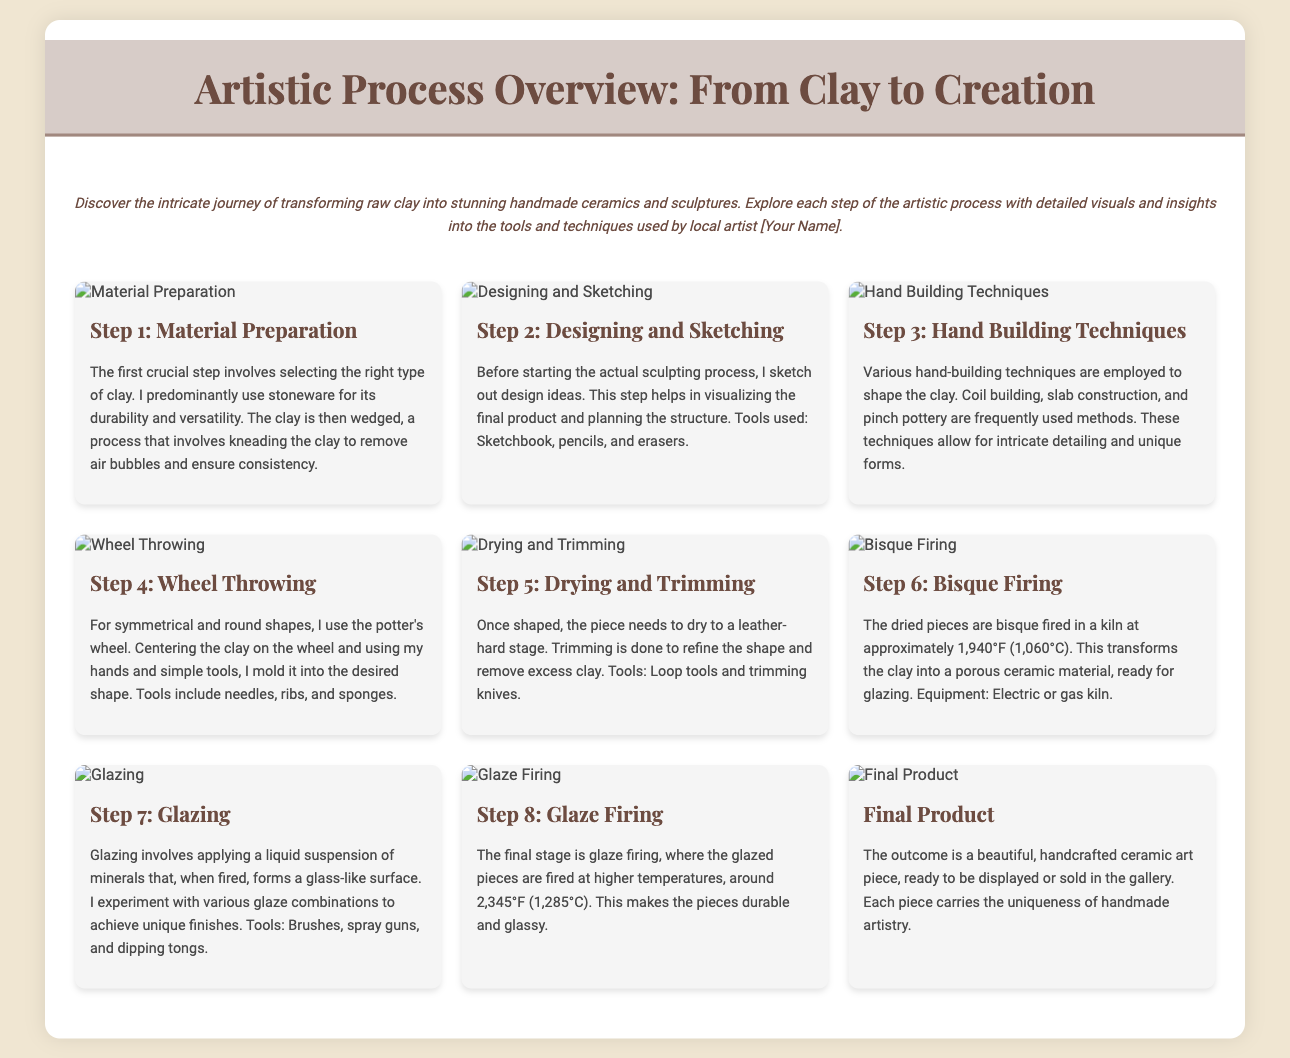what type of clay is predominantly used? The document states that stoneware is predominantly used for its durability and versatility.
Answer: stoneware what is the first step in the artistic process? The first step is Material Preparation, which includes selecting the right type of clay and wedging it.
Answer: Material Preparation which techniques are mentioned for shaping the clay? The document lists coil building, slab construction, and pinch pottery as the hand-building techniques used.
Answer: coil building, slab construction, pinch pottery what temperature is the bisque firing? The bisque firing is done at approximately 1,940°F (1,060°C).
Answer: 1,940°F (1,060°C) what tool is used during wheel throwing? The document mentions that needles, ribs, and sponges are tools used during wheel throwing.
Answer: needles, ribs, sponges how many steps are outlined in the artistic process? The document outlines a total of eight steps in the artistic process.
Answer: eight what is the final product described as? The final product is described as a beautiful, handcrafted ceramic art piece.
Answer: handcrafted ceramic art piece which method is specifically mentioned for refining shape after drying? The technique mentioned for refining shape after drying is trimming, using loop tools and trimming knives.
Answer: trimming what does glazing involve? Glazing involves applying a liquid suspension of minerals that forms a glass-like surface when fired.
Answer: applying a liquid suspension of minerals 